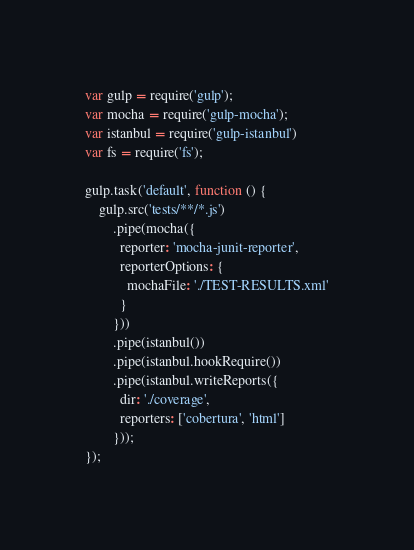Convert code to text. <code><loc_0><loc_0><loc_500><loc_500><_JavaScript_>var gulp = require('gulp');
var mocha = require('gulp-mocha');
var istanbul = require('gulp-istanbul')
var fs = require('fs');

gulp.task('default', function () {
    gulp.src('tests/**/*.js')
        .pipe(mocha({
          reporter: 'mocha-junit-reporter',
          reporterOptions: {
            mochaFile: './TEST-RESULTS.xml'
          }
        }))
        .pipe(istanbul())
        .pipe(istanbul.hookRequire())
        .pipe(istanbul.writeReports({
          dir: './coverage',
          reporters: ['cobertura', 'html'] 
        }));
});
</code> 